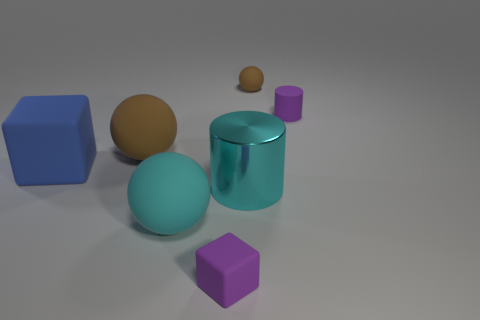Subtract all gray blocks. How many brown spheres are left? 2 Subtract all small balls. How many balls are left? 2 Add 2 metal objects. How many objects exist? 9 Subtract all gray spheres. Subtract all blue cylinders. How many spheres are left? 3 Subtract all cylinders. How many objects are left? 5 Subtract all blue matte blocks. Subtract all tiny objects. How many objects are left? 3 Add 5 large cyan metallic cylinders. How many large cyan metallic cylinders are left? 6 Add 6 big cyan matte things. How many big cyan matte things exist? 7 Subtract 0 gray spheres. How many objects are left? 7 